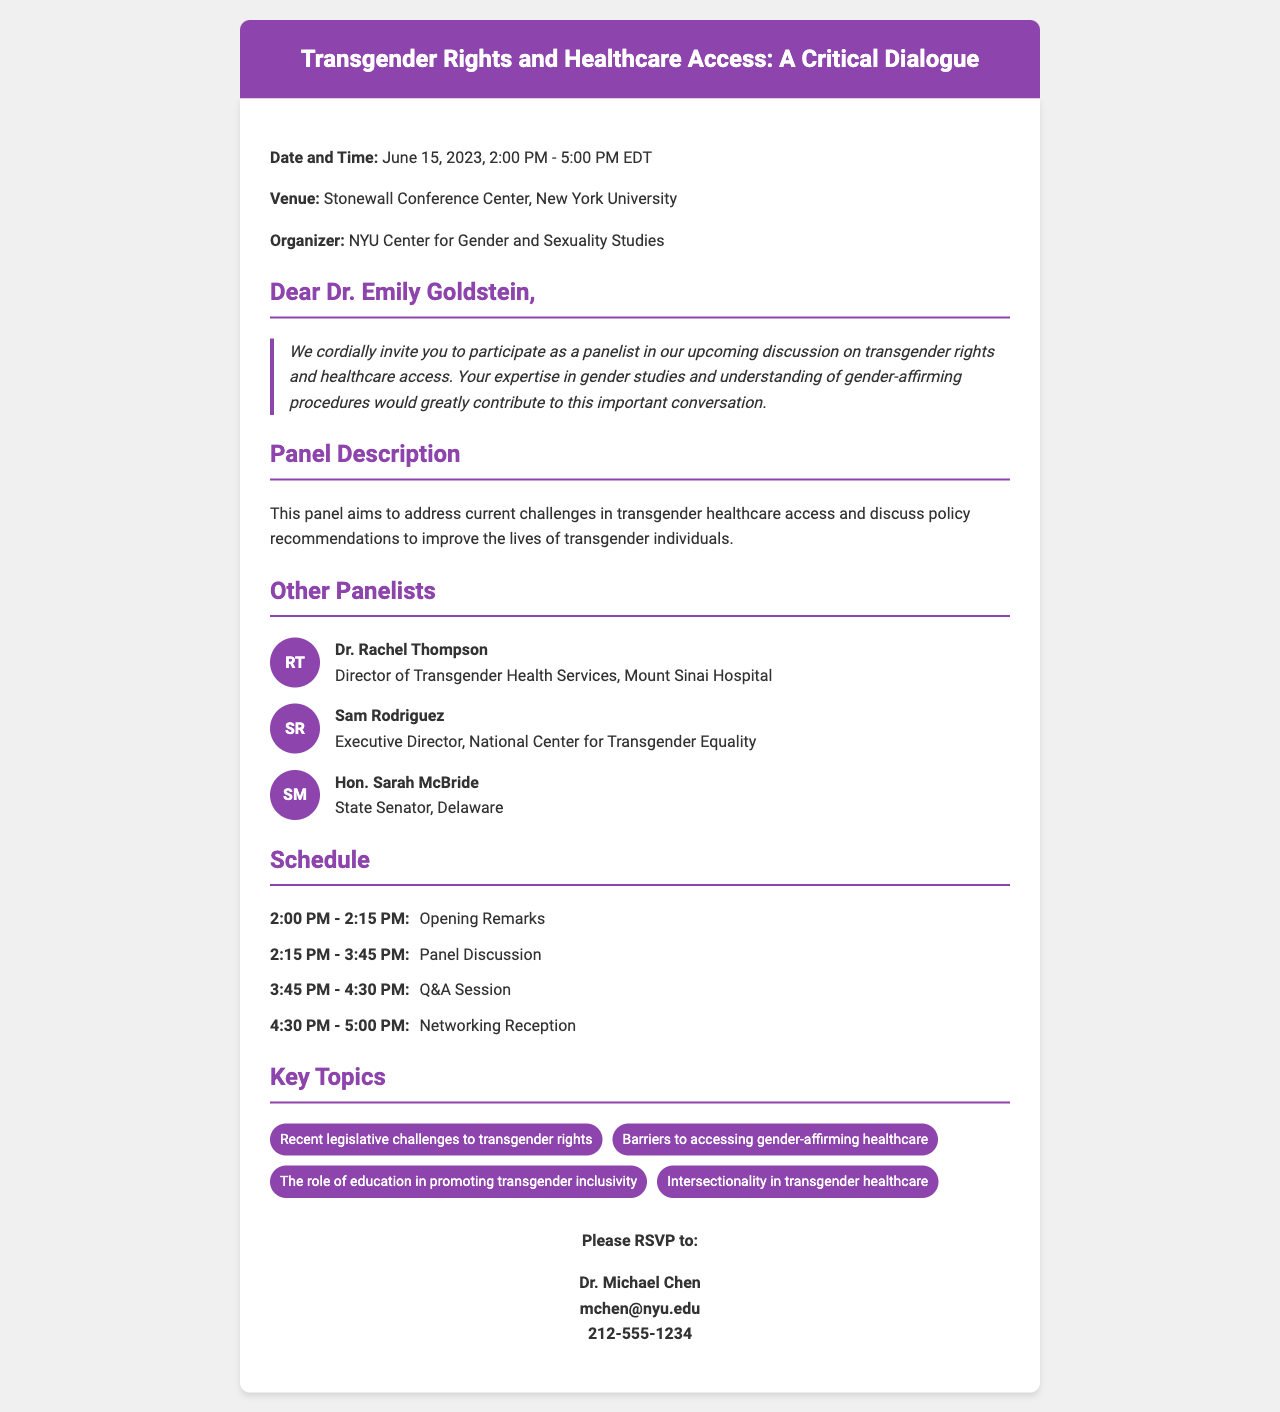What is the date of the event? The date is explicitly mentioned in the document as June 15, 2023.
Answer: June 15, 2023 Who is the organizer of the event? The organizer's name is stated clearly in the document as NYU Center for Gender and Sexuality Studies.
Answer: NYU Center for Gender and Sexuality Studies What is the venue for the panel discussion? The venue is specified in the document as Stonewall Conference Center, New York University.
Answer: Stonewall Conference Center, New York University Who are the other panelists apart from Dr. Emily Goldstein? The document lists Dr. Rachel Thompson, Sam Rodriguez, and Hon. Sarah McBride as other panelists.
Answer: Dr. Rachel Thompson, Sam Rodriguez, Hon. Sarah McBride What time does the networking reception start? The time for the networking reception is outlined in the document as 4:30 PM.
Answer: 4:30 PM What is the title of the panel discussion? The title is given at the top of the document as "Transgender Rights and Healthcare Access: A Critical Dialogue."
Answer: Transgender Rights and Healthcare Access: A Critical Dialogue What is the duration of the panel discussion? The duration is calculated based on the times given for the panel discussion, which spans from 2:15 PM to 3:45 PM.
Answer: 1.5 hours What is the main focus of the panel discussion? The document describes the main focus as addressing current challenges in transgender healthcare access and discussing policy recommendations.
Answer: Transgender healthcare access and policy recommendations 